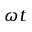Convert formula to latex. <formula><loc_0><loc_0><loc_500><loc_500>\omega t</formula> 